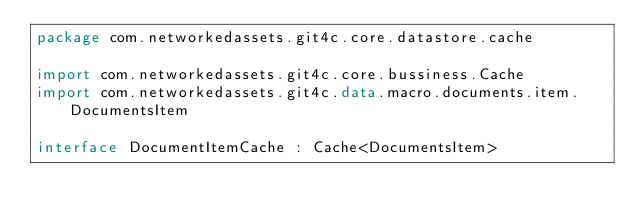<code> <loc_0><loc_0><loc_500><loc_500><_Kotlin_>package com.networkedassets.git4c.core.datastore.cache

import com.networkedassets.git4c.core.bussiness.Cache
import com.networkedassets.git4c.data.macro.documents.item.DocumentsItem

interface DocumentItemCache : Cache<DocumentsItem></code> 